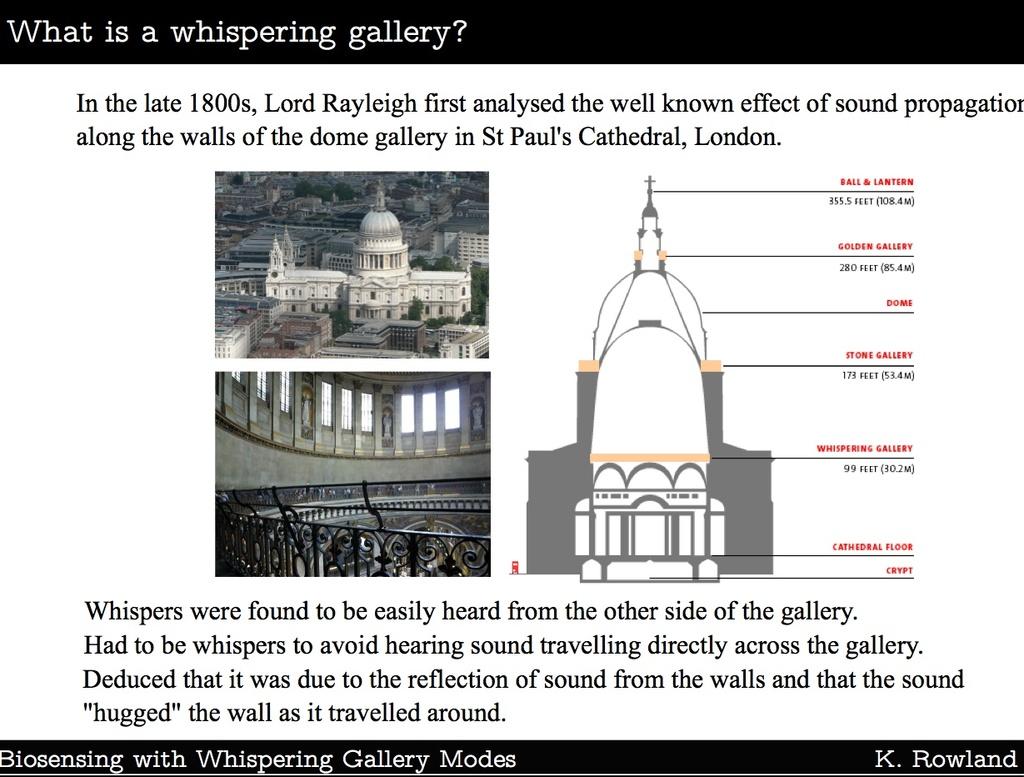Who is the author of this book?
Your answer should be very brief. K. rowland. Where did lord rayleigh perform his research?
Keep it short and to the point. St. paul's cathedral, london. 